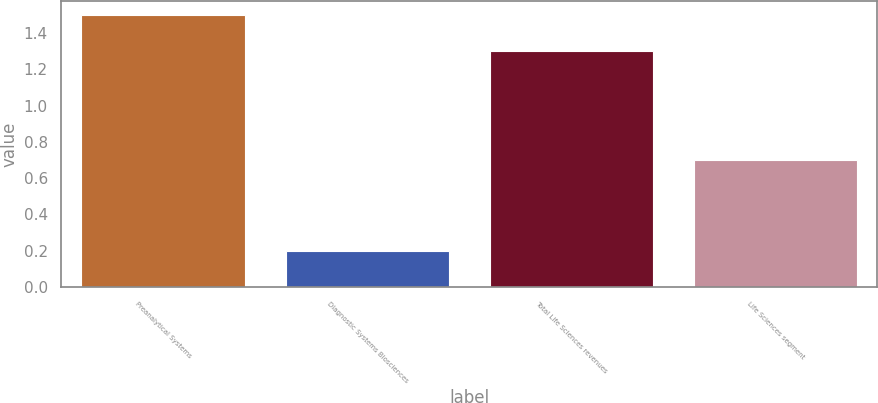Convert chart to OTSL. <chart><loc_0><loc_0><loc_500><loc_500><bar_chart><fcel>Preanalytical Systems<fcel>Diagnostic Systems Biosciences<fcel>Total Life Sciences revenues<fcel>Life Sciences segment<nl><fcel>1.5<fcel>0.2<fcel>1.3<fcel>0.7<nl></chart> 